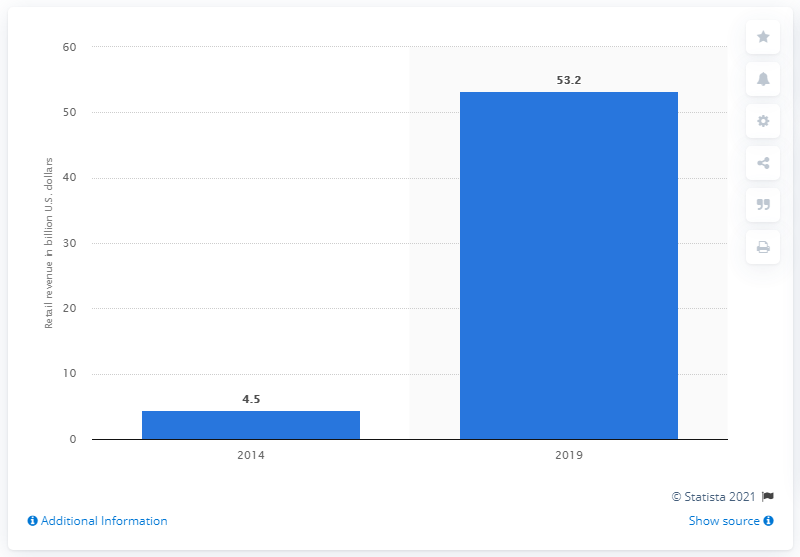List a handful of essential elements in this visual. The expected global retail revenue from smart wearable devices in 2019 is projected to reach 53.2 billion US dollars. 